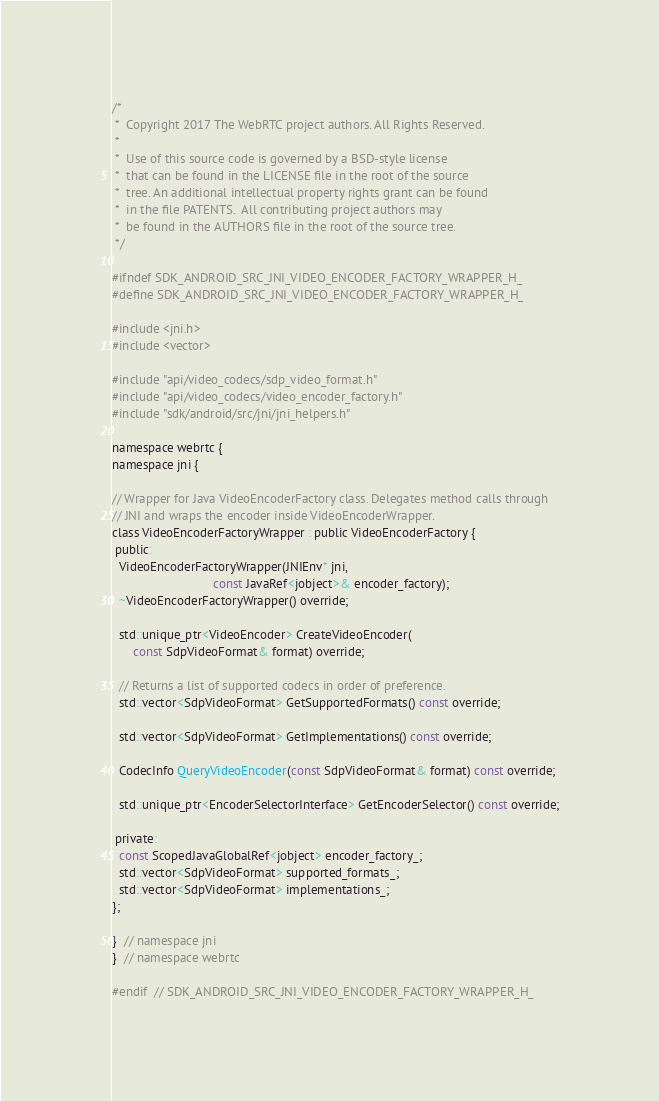Convert code to text. <code><loc_0><loc_0><loc_500><loc_500><_C_>/*
 *  Copyright 2017 The WebRTC project authors. All Rights Reserved.
 *
 *  Use of this source code is governed by a BSD-style license
 *  that can be found in the LICENSE file in the root of the source
 *  tree. An additional intellectual property rights grant can be found
 *  in the file PATENTS.  All contributing project authors may
 *  be found in the AUTHORS file in the root of the source tree.
 */

#ifndef SDK_ANDROID_SRC_JNI_VIDEO_ENCODER_FACTORY_WRAPPER_H_
#define SDK_ANDROID_SRC_JNI_VIDEO_ENCODER_FACTORY_WRAPPER_H_

#include <jni.h>
#include <vector>

#include "api/video_codecs/sdp_video_format.h"
#include "api/video_codecs/video_encoder_factory.h"
#include "sdk/android/src/jni/jni_helpers.h"

namespace webrtc {
namespace jni {

// Wrapper for Java VideoEncoderFactory class. Delegates method calls through
// JNI and wraps the encoder inside VideoEncoderWrapper.
class VideoEncoderFactoryWrapper : public VideoEncoderFactory {
 public:
  VideoEncoderFactoryWrapper(JNIEnv* jni,
                             const JavaRef<jobject>& encoder_factory);
  ~VideoEncoderFactoryWrapper() override;

  std::unique_ptr<VideoEncoder> CreateVideoEncoder(
      const SdpVideoFormat& format) override;

  // Returns a list of supported codecs in order of preference.
  std::vector<SdpVideoFormat> GetSupportedFormats() const override;

  std::vector<SdpVideoFormat> GetImplementations() const override;

  CodecInfo QueryVideoEncoder(const SdpVideoFormat& format) const override;

  std::unique_ptr<EncoderSelectorInterface> GetEncoderSelector() const override;

 private:
  const ScopedJavaGlobalRef<jobject> encoder_factory_;
  std::vector<SdpVideoFormat> supported_formats_;
  std::vector<SdpVideoFormat> implementations_;
};

}  // namespace jni
}  // namespace webrtc

#endif  // SDK_ANDROID_SRC_JNI_VIDEO_ENCODER_FACTORY_WRAPPER_H_
</code> 